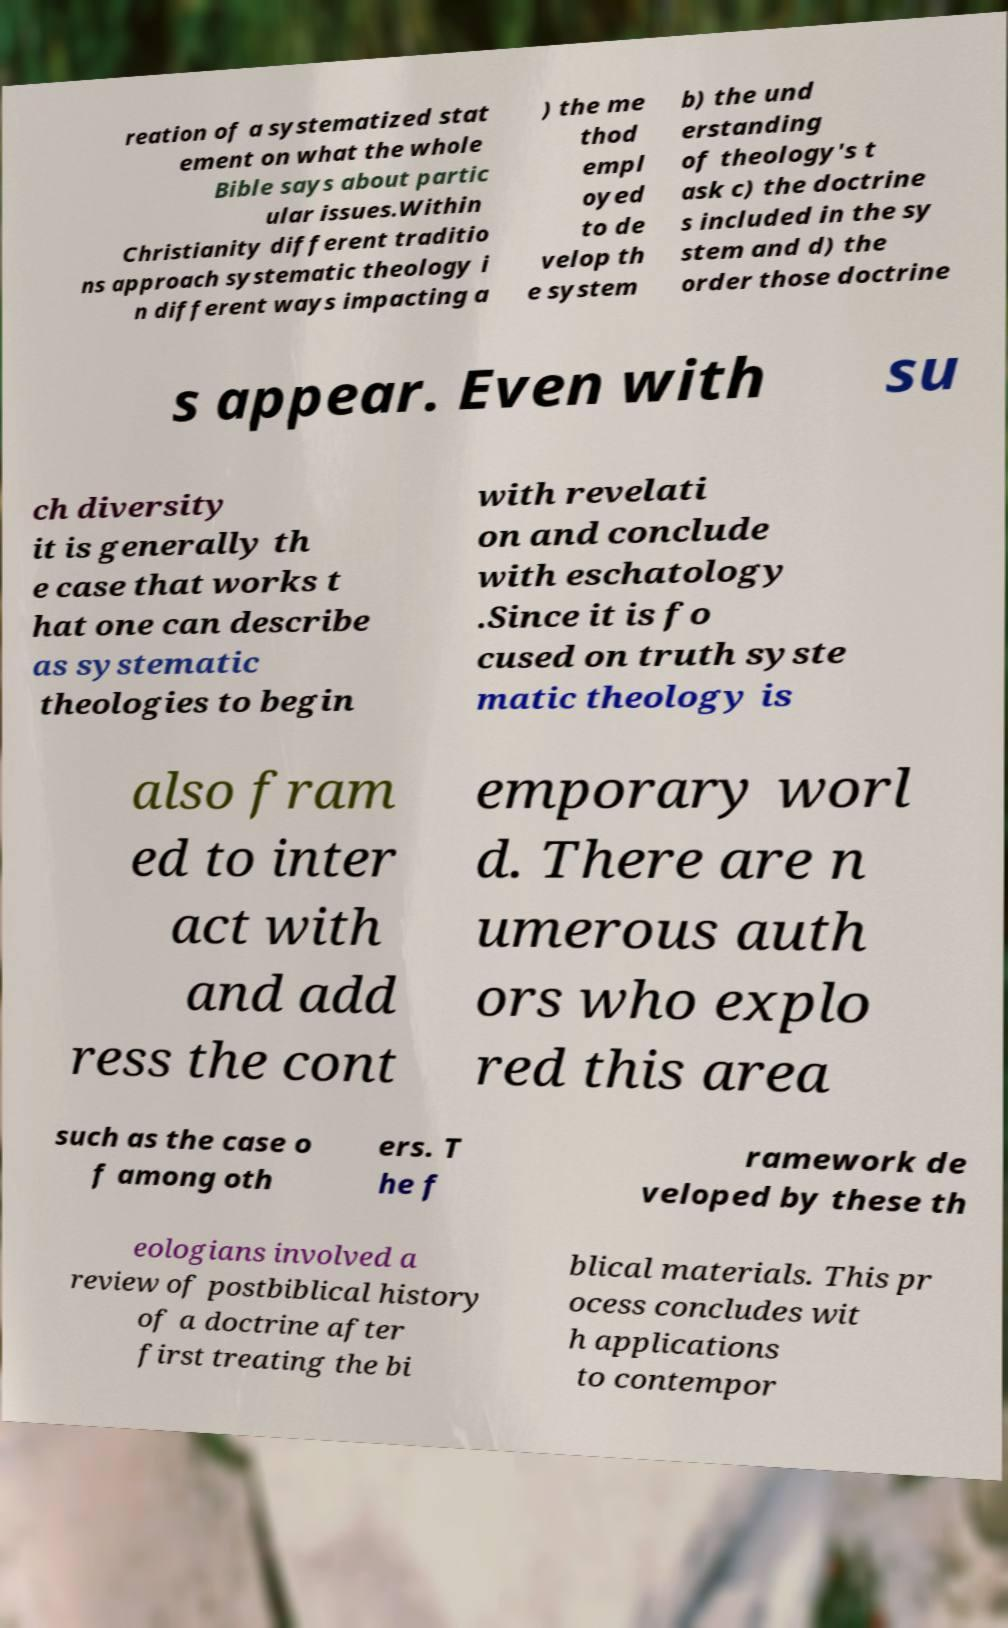Could you extract and type out the text from this image? reation of a systematized stat ement on what the whole Bible says about partic ular issues.Within Christianity different traditio ns approach systematic theology i n different ways impacting a ) the me thod empl oyed to de velop th e system b) the und erstanding of theology's t ask c) the doctrine s included in the sy stem and d) the order those doctrine s appear. Even with su ch diversity it is generally th e case that works t hat one can describe as systematic theologies to begin with revelati on and conclude with eschatology .Since it is fo cused on truth syste matic theology is also fram ed to inter act with and add ress the cont emporary worl d. There are n umerous auth ors who explo red this area such as the case o f among oth ers. T he f ramework de veloped by these th eologians involved a review of postbiblical history of a doctrine after first treating the bi blical materials. This pr ocess concludes wit h applications to contempor 